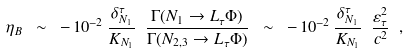<formula> <loc_0><loc_0><loc_500><loc_500>\eta _ { B } \ \sim \ - \, 1 0 ^ { - 2 } \, \frac { \delta ^ { \tau } _ { N _ { 1 } } } { K _ { N _ { 1 } } } \ \frac { \Gamma ( N _ { 1 } \to L _ { \tau } \Phi ) } { \Gamma ( N _ { 2 , 3 } \to L _ { \tau } \Phi ) } \ \sim \ - \, 1 0 ^ { - 2 } \, \frac { \delta ^ { \tau } _ { N _ { 1 } } } { K _ { N _ { 1 } } } \ \frac { \varepsilon ^ { 2 } _ { \tau } } { c ^ { 2 } } \ ,</formula> 